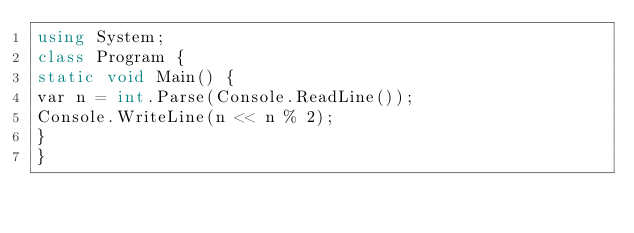<code> <loc_0><loc_0><loc_500><loc_500><_C#_>using System;
class Program {
static void Main() {
var n = int.Parse(Console.ReadLine());
Console.WriteLine(n << n % 2);
}
}
</code> 